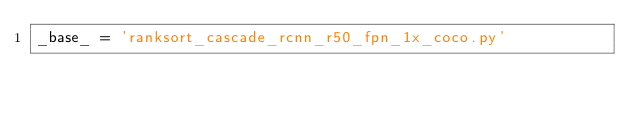<code> <loc_0><loc_0><loc_500><loc_500><_Python_>_base_ = 'ranksort_cascade_rcnn_r50_fpn_1x_coco.py'</code> 